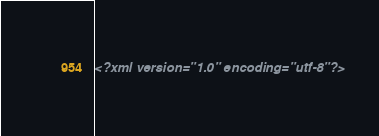<code> <loc_0><loc_0><loc_500><loc_500><_XML_><?xml version="1.0" encoding="utf-8"?></code> 